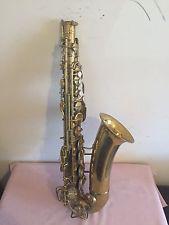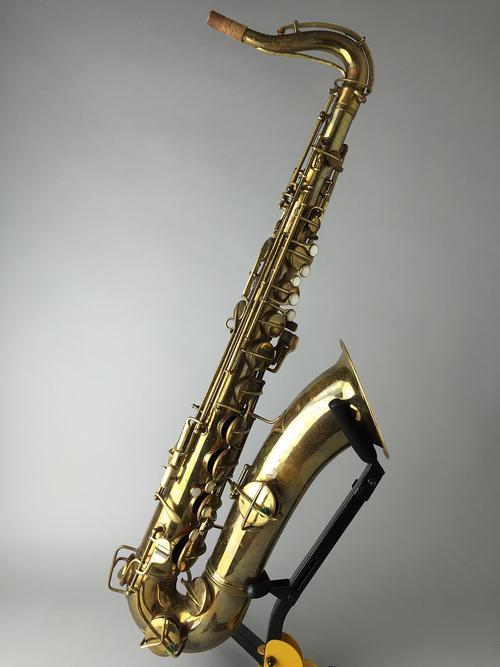The first image is the image on the left, the second image is the image on the right. Assess this claim about the two images: "An image shows a brass-colored saxophone held upright on a blacks stand.". Correct or not? Answer yes or no. Yes. The first image is the image on the left, the second image is the image on the right. Given the left and right images, does the statement "A saxophone is on a stand in the right image." hold true? Answer yes or no. Yes. 